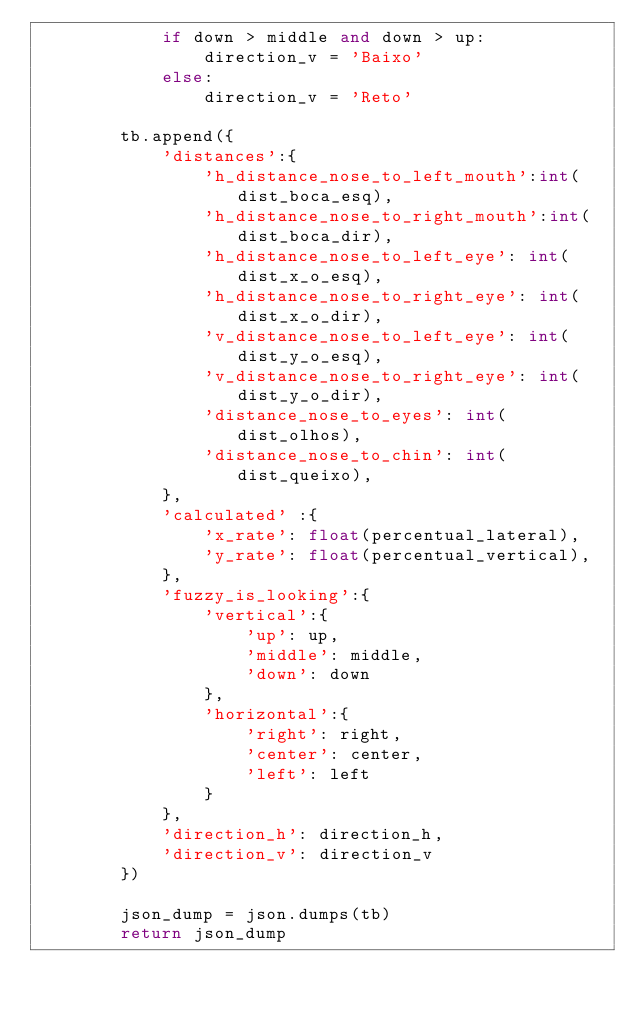Convert code to text. <code><loc_0><loc_0><loc_500><loc_500><_Python_>            if down > middle and down > up:
                direction_v = 'Baixo'
            else:
                direction_v = 'Reto' 

        tb.append({
            'distances':{
                'h_distance_nose_to_left_mouth':int(dist_boca_esq),
                'h_distance_nose_to_right_mouth':int(dist_boca_dir),
                'h_distance_nose_to_left_eye': int(dist_x_o_esq),
                'h_distance_nose_to_right_eye': int(dist_x_o_dir),
                'v_distance_nose_to_left_eye': int(dist_y_o_esq),
                'v_distance_nose_to_right_eye': int(dist_y_o_dir),
                'distance_nose_to_eyes': int(dist_olhos),
                'distance_nose_to_chin': int(dist_queixo),
            },
            'calculated' :{
                'x_rate': float(percentual_lateral),
                'y_rate': float(percentual_vertical),
            },          
            'fuzzy_is_looking':{
                'vertical':{
                    'up': up,
                    'middle': middle,
                    'down': down
                },
                'horizontal':{  
                    'right': right,
                    'center': center,
                    'left': left
                }
            },
            'direction_h': direction_h,
            'direction_v': direction_v
        })

        json_dump = json.dumps(tb)
        return json_dump</code> 